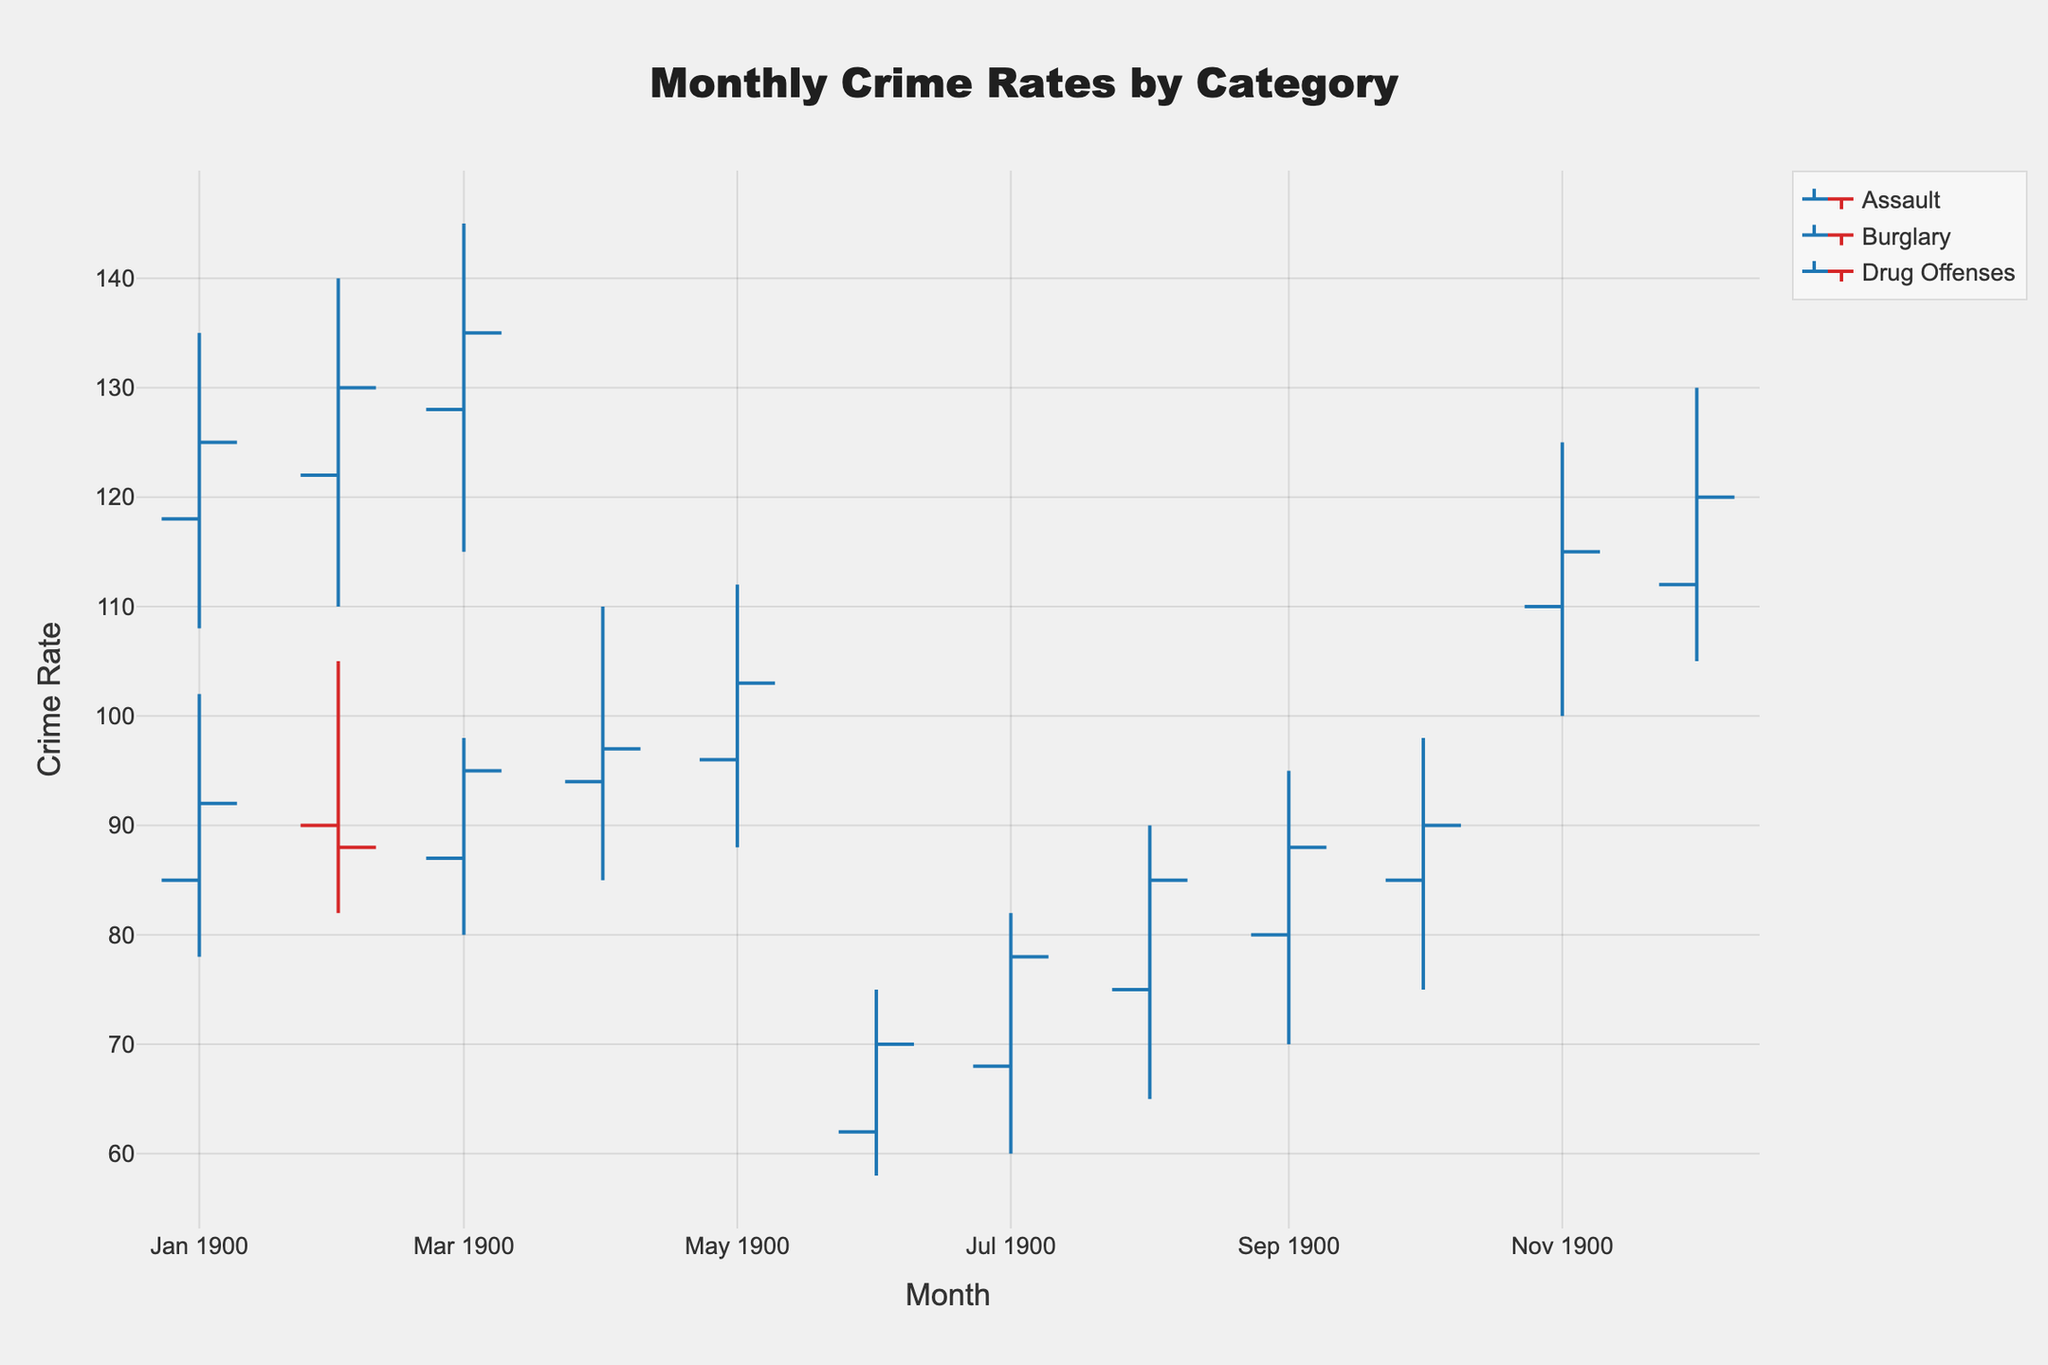What is the title of the chart? The title is usually displayed prominently at the top of the chart. In this case, it summarizes the topic being visualized by the OHLC chart as "Monthly Crime Rates by Category".
Answer: Monthly Crime Rates by Category Which crime category shows data starting from January? By looking at the data categories and the months associated with them, we can see that "Burglary" starts from January, as indicated in the figure.
Answer: Burglary Which month has the highest close rate for Burglary? The close rates for Burglary are indicated on the OHLC chart by the closing value at the end of each month. For Burglary, the months listed have respective close rates, and the highest one in the figure is for May.
Answer: May In which month did Assault have the lowest crime rate? By looking at the low values for Assault for each month listed, we can see which one is minimum. From the chart, the lowest value (58) can be found in June.
Answer: June How many data points are there for Drug Offenses? Each OHLC bar represents a data point for a specific month. By counting the number of bars shown for Drug Offenses in the figure, we determine the total. There are listings for Nov, Dec, Jan, Feb, and Mar.
Answer: 5 What's the average closing rate for Drug Offenses from November to March? Summing up the closing rates for Drug Offenses from Nov (115), Dec (120), Jan (125), Feb (130), and Mar (135), we get a total of 625. Dividing this by the number of months (5) gives the average.
Answer: 125 Which crime type had an increasing close rate from February to March? By observing the closing rates for each crime type from Feb to Mar, we can identify upward trends. Burglary had a closing rate increase (88 to 95), and Drug Offenses had an increase (130 to 135).
Answer: Burglary, Drug Offenses Compare the high rates of Burglary in January and July. Which month has a higher rate? Checking the 'high' values on the chart for Burglary in January (102) and July (not listed, thus irrelevant), only January is observed. Thus, January is higher by default in comparison.
Answer: January During which month did Assault see the highest volatility? Volatility can be interpreted from the range between the 'high' and 'low' values for a given period. Checking these ranges for each month, we find the largest difference in values (90-65 = 25) occurring in August.
Answer: August 